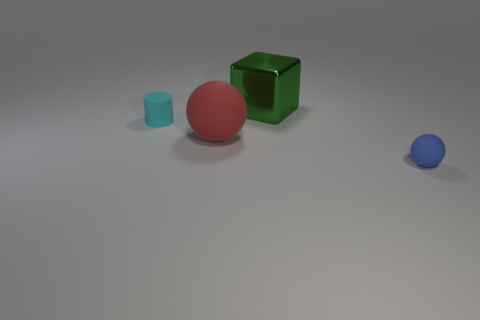How many things are either rubber balls or yellow rubber spheres?
Provide a succinct answer. 2. What is the material of the sphere that is to the left of the tiny object that is in front of the big red matte thing?
Ensure brevity in your answer.  Rubber. Are there any large metal things of the same color as the small rubber ball?
Keep it short and to the point. No. The shiny thing that is the same size as the red ball is what color?
Provide a succinct answer. Green. What material is the cube to the right of the small thing on the left side of the tiny thing in front of the small cyan cylinder made of?
Offer a terse response. Metal. There is a cylinder; is it the same color as the sphere that is in front of the big matte sphere?
Your answer should be compact. No. What number of objects are rubber objects that are in front of the rubber cylinder or balls to the left of the small rubber ball?
Give a very brief answer. 2. The tiny rubber thing that is in front of the matte sphere behind the tiny blue rubber sphere is what shape?
Your answer should be compact. Sphere. Are there any other red objects that have the same material as the red thing?
Ensure brevity in your answer.  No. The other matte object that is the same shape as the tiny blue object is what color?
Ensure brevity in your answer.  Red. 